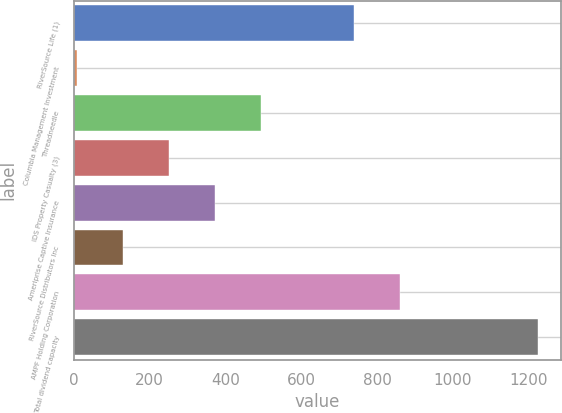Convert chart to OTSL. <chart><loc_0><loc_0><loc_500><loc_500><bar_chart><fcel>RiverSource Life (1)<fcel>Columbia Management Investment<fcel>Threadneedle<fcel>IDS Property Casualty (3)<fcel>Ameriprise Captive Insurance<fcel>RiverSource Distributors Inc<fcel>AMPF Holding Corporation<fcel>Total dividend capacity<nl><fcel>738<fcel>9<fcel>495<fcel>252<fcel>373.5<fcel>130.5<fcel>859.5<fcel>1224<nl></chart> 